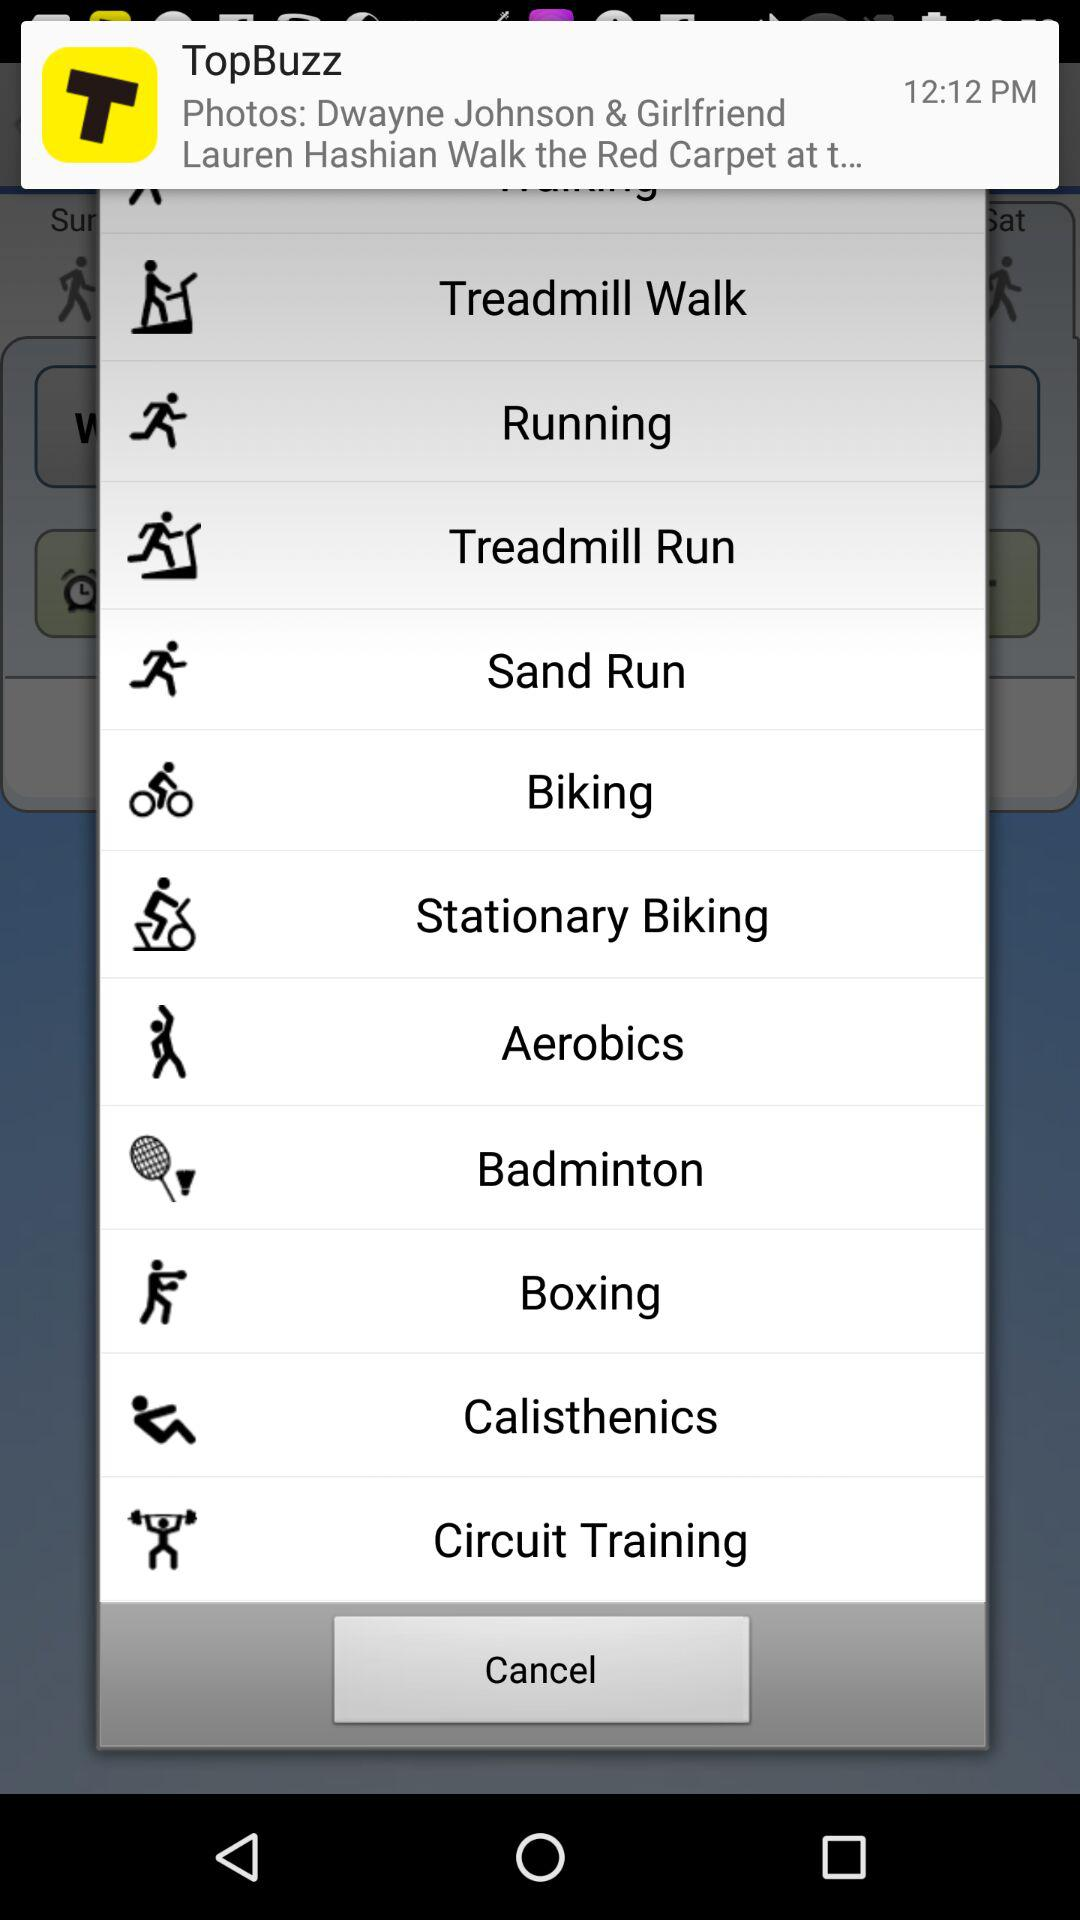What is the time of notification? The time is 12:12 PM. 